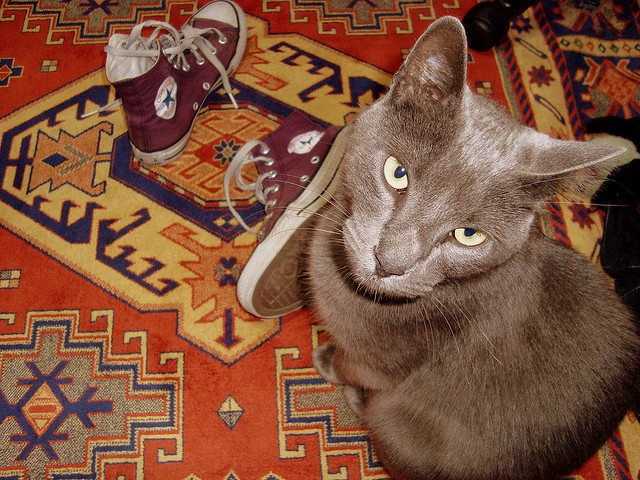Describe the objects in this image and their specific colors. I can see a cat in maroon and gray tones in this image. 